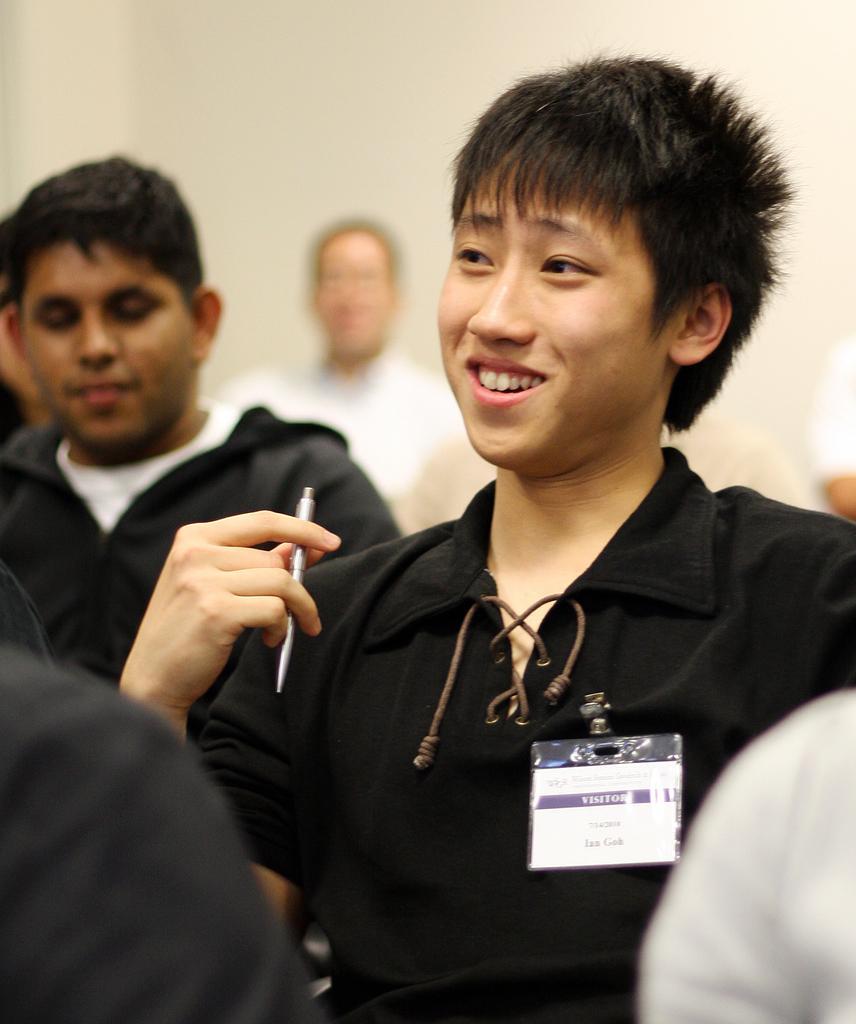Please provide a concise description of this image. In this image we can see one white wall, so many people are sitting and one person with ID card holding a pen. 